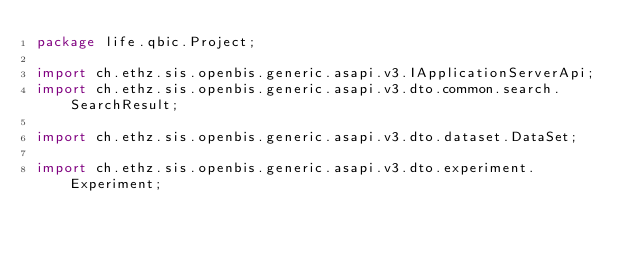<code> <loc_0><loc_0><loc_500><loc_500><_Java_>package life.qbic.Project;

import ch.ethz.sis.openbis.generic.asapi.v3.IApplicationServerApi;
import ch.ethz.sis.openbis.generic.asapi.v3.dto.common.search.SearchResult;

import ch.ethz.sis.openbis.generic.asapi.v3.dto.dataset.DataSet;

import ch.ethz.sis.openbis.generic.asapi.v3.dto.experiment.Experiment;</code> 